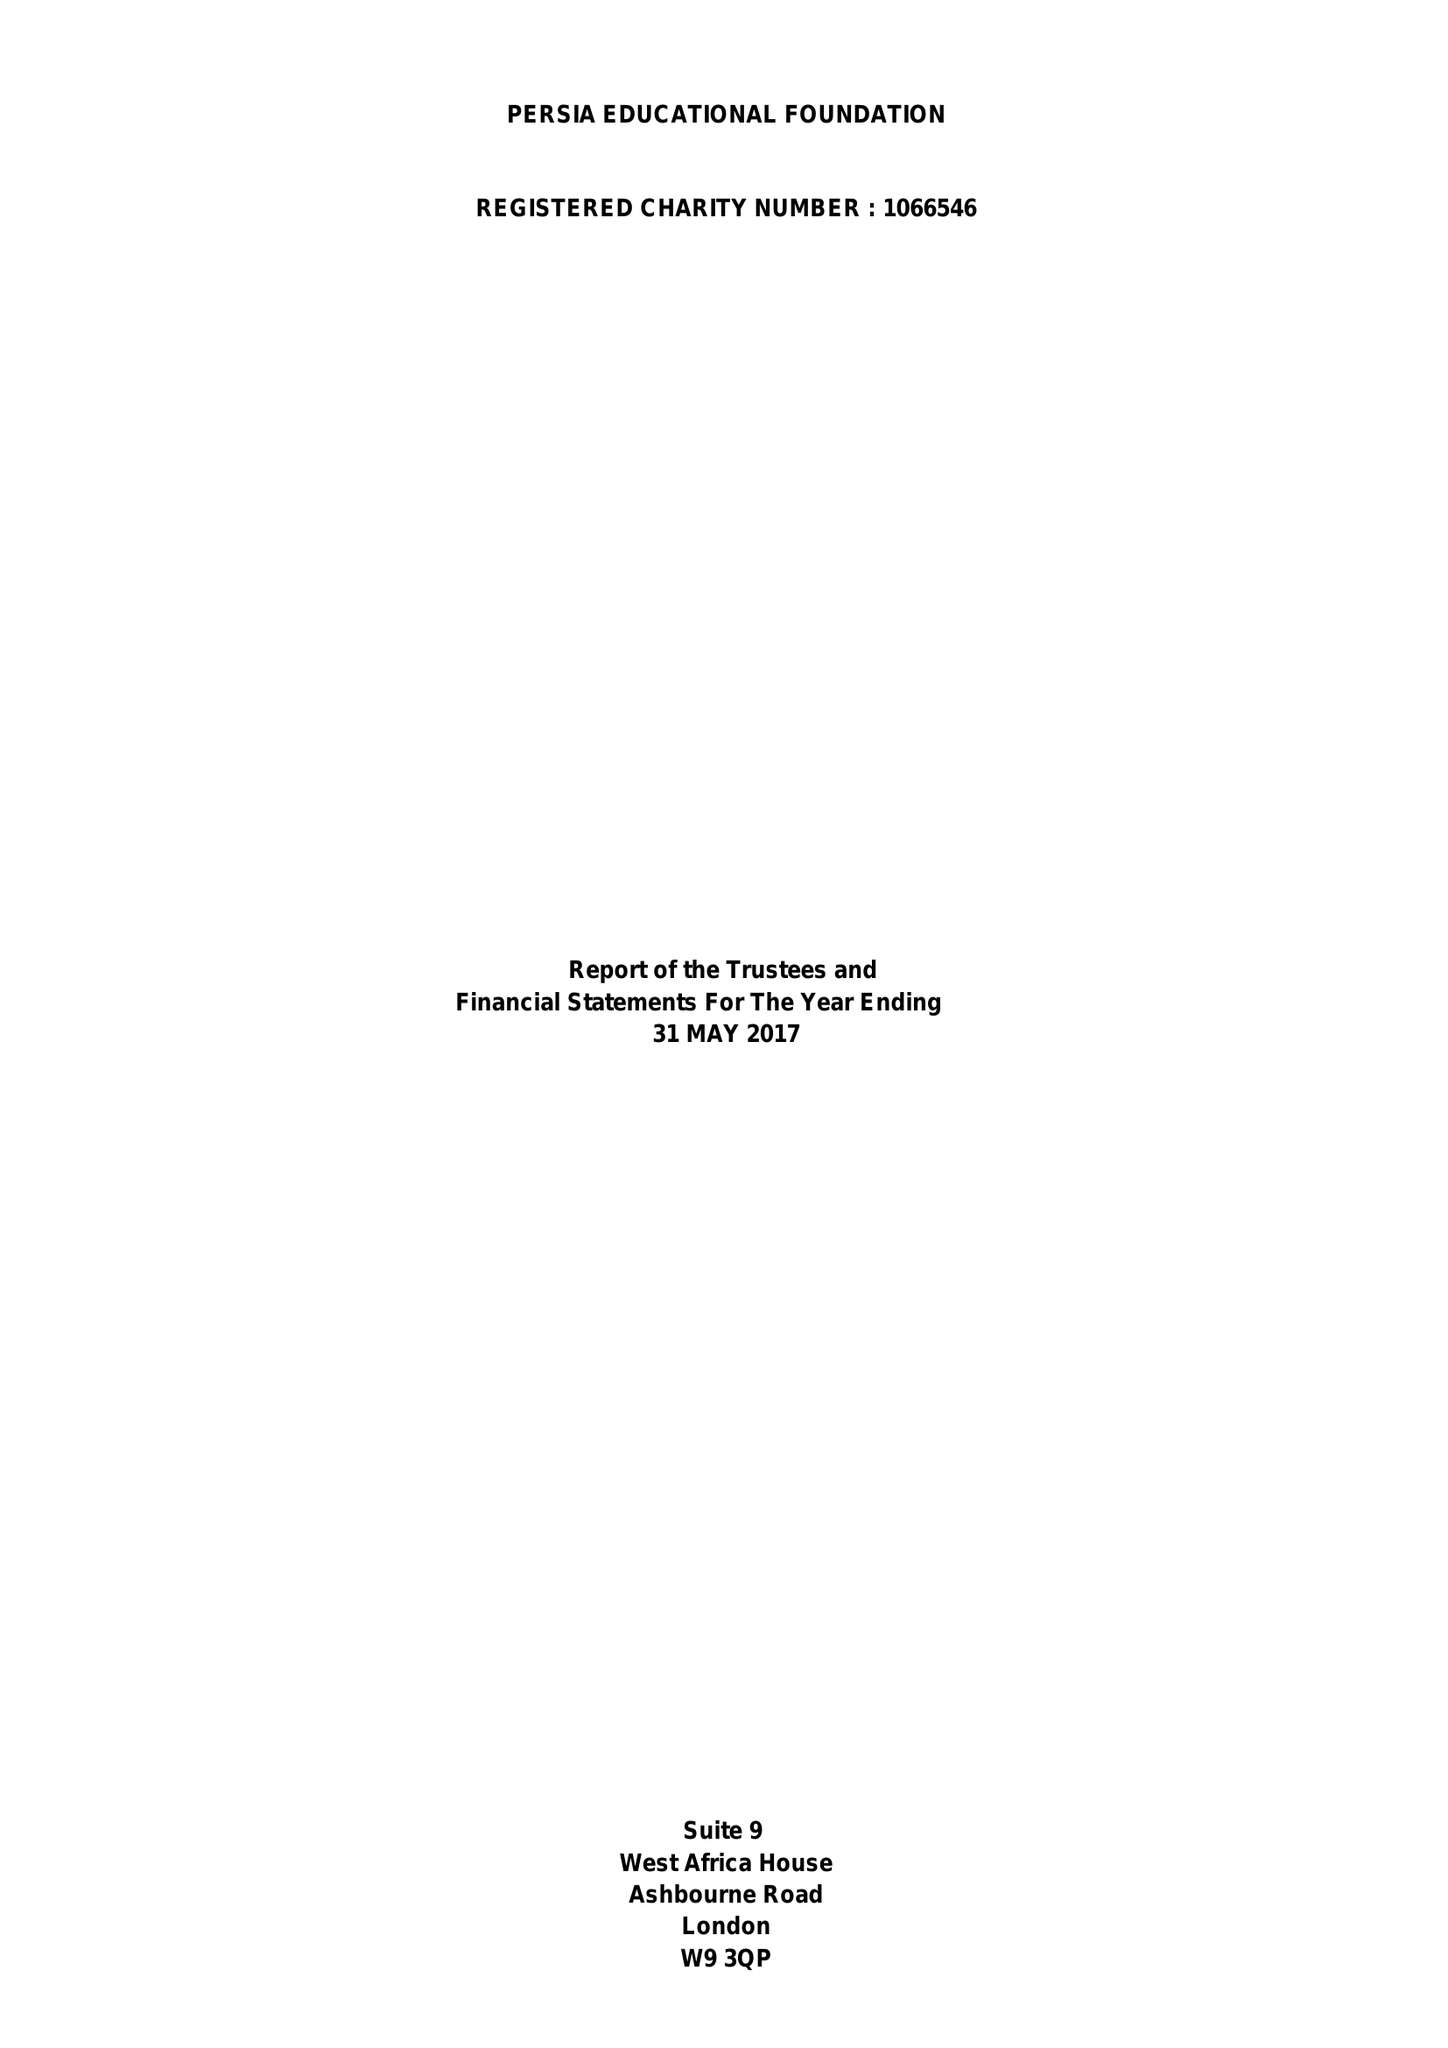What is the value for the income_annually_in_british_pounds?
Answer the question using a single word or phrase. 30858.00 